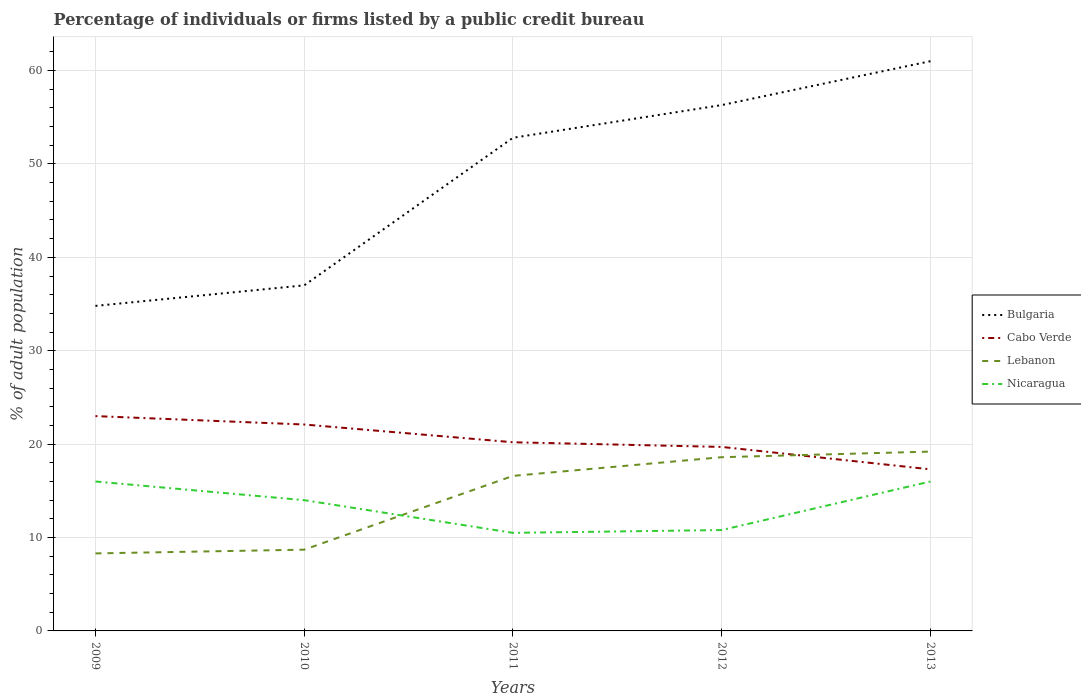Does the line corresponding to Cabo Verde intersect with the line corresponding to Bulgaria?
Your answer should be compact. No. Is the number of lines equal to the number of legend labels?
Keep it short and to the point. Yes. What is the total percentage of population listed by a public credit bureau in Lebanon in the graph?
Provide a short and direct response. -0.4. What is the difference between the highest and the second highest percentage of population listed by a public credit bureau in Lebanon?
Make the answer very short. 10.9. What is the difference between the highest and the lowest percentage of population listed by a public credit bureau in Lebanon?
Ensure brevity in your answer.  3. Is the percentage of population listed by a public credit bureau in Nicaragua strictly greater than the percentage of population listed by a public credit bureau in Lebanon over the years?
Your answer should be compact. No. How many years are there in the graph?
Keep it short and to the point. 5. What is the difference between two consecutive major ticks on the Y-axis?
Give a very brief answer. 10. Does the graph contain grids?
Your answer should be compact. Yes. How many legend labels are there?
Give a very brief answer. 4. What is the title of the graph?
Keep it short and to the point. Percentage of individuals or firms listed by a public credit bureau. What is the label or title of the X-axis?
Provide a succinct answer. Years. What is the label or title of the Y-axis?
Ensure brevity in your answer.  % of adult population. What is the % of adult population of Bulgaria in 2009?
Offer a terse response. 34.8. What is the % of adult population of Lebanon in 2009?
Your answer should be compact. 8.3. What is the % of adult population in Nicaragua in 2009?
Offer a terse response. 16. What is the % of adult population of Bulgaria in 2010?
Make the answer very short. 37. What is the % of adult population of Cabo Verde in 2010?
Your answer should be compact. 22.1. What is the % of adult population of Lebanon in 2010?
Provide a succinct answer. 8.7. What is the % of adult population of Nicaragua in 2010?
Provide a succinct answer. 14. What is the % of adult population of Bulgaria in 2011?
Your answer should be compact. 52.8. What is the % of adult population of Cabo Verde in 2011?
Provide a short and direct response. 20.2. What is the % of adult population of Bulgaria in 2012?
Make the answer very short. 56.3. What is the % of adult population in Lebanon in 2012?
Your response must be concise. 18.6. What is the % of adult population of Bulgaria in 2013?
Make the answer very short. 61. What is the % of adult population of Cabo Verde in 2013?
Keep it short and to the point. 17.3. What is the % of adult population in Lebanon in 2013?
Make the answer very short. 19.2. What is the % of adult population of Nicaragua in 2013?
Provide a succinct answer. 16. Across all years, what is the maximum % of adult population in Bulgaria?
Make the answer very short. 61. Across all years, what is the maximum % of adult population of Cabo Verde?
Offer a terse response. 23. Across all years, what is the maximum % of adult population of Lebanon?
Offer a very short reply. 19.2. Across all years, what is the maximum % of adult population in Nicaragua?
Give a very brief answer. 16. Across all years, what is the minimum % of adult population in Bulgaria?
Offer a very short reply. 34.8. Across all years, what is the minimum % of adult population of Cabo Verde?
Provide a short and direct response. 17.3. Across all years, what is the minimum % of adult population in Nicaragua?
Ensure brevity in your answer.  10.5. What is the total % of adult population in Bulgaria in the graph?
Your response must be concise. 241.9. What is the total % of adult population of Cabo Verde in the graph?
Provide a succinct answer. 102.3. What is the total % of adult population of Lebanon in the graph?
Offer a terse response. 71.4. What is the total % of adult population in Nicaragua in the graph?
Provide a succinct answer. 67.3. What is the difference between the % of adult population in Cabo Verde in 2009 and that in 2010?
Offer a terse response. 0.9. What is the difference between the % of adult population in Nicaragua in 2009 and that in 2010?
Give a very brief answer. 2. What is the difference between the % of adult population of Bulgaria in 2009 and that in 2011?
Give a very brief answer. -18. What is the difference between the % of adult population in Cabo Verde in 2009 and that in 2011?
Offer a terse response. 2.8. What is the difference between the % of adult population in Nicaragua in 2009 and that in 2011?
Provide a succinct answer. 5.5. What is the difference between the % of adult population in Bulgaria in 2009 and that in 2012?
Provide a succinct answer. -21.5. What is the difference between the % of adult population in Cabo Verde in 2009 and that in 2012?
Keep it short and to the point. 3.3. What is the difference between the % of adult population in Bulgaria in 2009 and that in 2013?
Offer a terse response. -26.2. What is the difference between the % of adult population of Nicaragua in 2009 and that in 2013?
Your response must be concise. 0. What is the difference between the % of adult population of Bulgaria in 2010 and that in 2011?
Offer a terse response. -15.8. What is the difference between the % of adult population in Cabo Verde in 2010 and that in 2011?
Your answer should be compact. 1.9. What is the difference between the % of adult population of Nicaragua in 2010 and that in 2011?
Provide a succinct answer. 3.5. What is the difference between the % of adult population of Bulgaria in 2010 and that in 2012?
Ensure brevity in your answer.  -19.3. What is the difference between the % of adult population of Lebanon in 2010 and that in 2012?
Offer a very short reply. -9.9. What is the difference between the % of adult population of Bulgaria in 2010 and that in 2013?
Your answer should be very brief. -24. What is the difference between the % of adult population in Lebanon in 2010 and that in 2013?
Give a very brief answer. -10.5. What is the difference between the % of adult population in Bulgaria in 2011 and that in 2012?
Offer a very short reply. -3.5. What is the difference between the % of adult population of Lebanon in 2011 and that in 2012?
Give a very brief answer. -2. What is the difference between the % of adult population in Nicaragua in 2011 and that in 2012?
Provide a short and direct response. -0.3. What is the difference between the % of adult population of Cabo Verde in 2011 and that in 2013?
Ensure brevity in your answer.  2.9. What is the difference between the % of adult population of Lebanon in 2011 and that in 2013?
Provide a succinct answer. -2.6. What is the difference between the % of adult population in Bulgaria in 2012 and that in 2013?
Provide a short and direct response. -4.7. What is the difference between the % of adult population in Bulgaria in 2009 and the % of adult population in Lebanon in 2010?
Provide a succinct answer. 26.1. What is the difference between the % of adult population of Bulgaria in 2009 and the % of adult population of Nicaragua in 2010?
Give a very brief answer. 20.8. What is the difference between the % of adult population in Cabo Verde in 2009 and the % of adult population in Nicaragua in 2010?
Your answer should be compact. 9. What is the difference between the % of adult population of Bulgaria in 2009 and the % of adult population of Cabo Verde in 2011?
Your answer should be compact. 14.6. What is the difference between the % of adult population of Bulgaria in 2009 and the % of adult population of Nicaragua in 2011?
Keep it short and to the point. 24.3. What is the difference between the % of adult population in Cabo Verde in 2009 and the % of adult population in Lebanon in 2011?
Your answer should be very brief. 6.4. What is the difference between the % of adult population of Bulgaria in 2010 and the % of adult population of Lebanon in 2011?
Your answer should be compact. 20.4. What is the difference between the % of adult population of Cabo Verde in 2010 and the % of adult population of Lebanon in 2011?
Your answer should be very brief. 5.5. What is the difference between the % of adult population in Bulgaria in 2010 and the % of adult population in Lebanon in 2012?
Keep it short and to the point. 18.4. What is the difference between the % of adult population of Bulgaria in 2010 and the % of adult population of Nicaragua in 2012?
Give a very brief answer. 26.2. What is the difference between the % of adult population in Cabo Verde in 2010 and the % of adult population in Lebanon in 2012?
Make the answer very short. 3.5. What is the difference between the % of adult population of Cabo Verde in 2010 and the % of adult population of Nicaragua in 2012?
Your response must be concise. 11.3. What is the difference between the % of adult population of Lebanon in 2010 and the % of adult population of Nicaragua in 2012?
Keep it short and to the point. -2.1. What is the difference between the % of adult population in Bulgaria in 2010 and the % of adult population in Lebanon in 2013?
Provide a succinct answer. 17.8. What is the difference between the % of adult population of Bulgaria in 2010 and the % of adult population of Nicaragua in 2013?
Your answer should be very brief. 21. What is the difference between the % of adult population of Lebanon in 2010 and the % of adult population of Nicaragua in 2013?
Ensure brevity in your answer.  -7.3. What is the difference between the % of adult population in Bulgaria in 2011 and the % of adult population in Cabo Verde in 2012?
Provide a succinct answer. 33.1. What is the difference between the % of adult population of Bulgaria in 2011 and the % of adult population of Lebanon in 2012?
Your response must be concise. 34.2. What is the difference between the % of adult population in Bulgaria in 2011 and the % of adult population in Nicaragua in 2012?
Your answer should be compact. 42. What is the difference between the % of adult population of Lebanon in 2011 and the % of adult population of Nicaragua in 2012?
Offer a very short reply. 5.8. What is the difference between the % of adult population in Bulgaria in 2011 and the % of adult population in Cabo Verde in 2013?
Your answer should be very brief. 35.5. What is the difference between the % of adult population in Bulgaria in 2011 and the % of adult population in Lebanon in 2013?
Provide a short and direct response. 33.6. What is the difference between the % of adult population of Bulgaria in 2011 and the % of adult population of Nicaragua in 2013?
Your response must be concise. 36.8. What is the difference between the % of adult population in Cabo Verde in 2011 and the % of adult population in Nicaragua in 2013?
Keep it short and to the point. 4.2. What is the difference between the % of adult population in Bulgaria in 2012 and the % of adult population in Lebanon in 2013?
Make the answer very short. 37.1. What is the difference between the % of adult population of Bulgaria in 2012 and the % of adult population of Nicaragua in 2013?
Offer a very short reply. 40.3. What is the difference between the % of adult population of Cabo Verde in 2012 and the % of adult population of Nicaragua in 2013?
Keep it short and to the point. 3.7. What is the average % of adult population of Bulgaria per year?
Make the answer very short. 48.38. What is the average % of adult population in Cabo Verde per year?
Ensure brevity in your answer.  20.46. What is the average % of adult population in Lebanon per year?
Your answer should be compact. 14.28. What is the average % of adult population in Nicaragua per year?
Offer a very short reply. 13.46. In the year 2009, what is the difference between the % of adult population in Bulgaria and % of adult population in Cabo Verde?
Provide a succinct answer. 11.8. In the year 2009, what is the difference between the % of adult population in Bulgaria and % of adult population in Nicaragua?
Provide a short and direct response. 18.8. In the year 2009, what is the difference between the % of adult population of Cabo Verde and % of adult population of Nicaragua?
Your response must be concise. 7. In the year 2010, what is the difference between the % of adult population of Bulgaria and % of adult population of Cabo Verde?
Offer a very short reply. 14.9. In the year 2010, what is the difference between the % of adult population in Bulgaria and % of adult population in Lebanon?
Keep it short and to the point. 28.3. In the year 2010, what is the difference between the % of adult population in Bulgaria and % of adult population in Nicaragua?
Your answer should be compact. 23. In the year 2010, what is the difference between the % of adult population of Cabo Verde and % of adult population of Lebanon?
Offer a terse response. 13.4. In the year 2011, what is the difference between the % of adult population of Bulgaria and % of adult population of Cabo Verde?
Offer a terse response. 32.6. In the year 2011, what is the difference between the % of adult population of Bulgaria and % of adult population of Lebanon?
Offer a very short reply. 36.2. In the year 2011, what is the difference between the % of adult population in Bulgaria and % of adult population in Nicaragua?
Make the answer very short. 42.3. In the year 2011, what is the difference between the % of adult population of Cabo Verde and % of adult population of Lebanon?
Provide a succinct answer. 3.6. In the year 2011, what is the difference between the % of adult population in Lebanon and % of adult population in Nicaragua?
Make the answer very short. 6.1. In the year 2012, what is the difference between the % of adult population of Bulgaria and % of adult population of Cabo Verde?
Your answer should be very brief. 36.6. In the year 2012, what is the difference between the % of adult population of Bulgaria and % of adult population of Lebanon?
Make the answer very short. 37.7. In the year 2012, what is the difference between the % of adult population in Bulgaria and % of adult population in Nicaragua?
Ensure brevity in your answer.  45.5. In the year 2012, what is the difference between the % of adult population of Cabo Verde and % of adult population of Lebanon?
Your answer should be very brief. 1.1. In the year 2012, what is the difference between the % of adult population in Cabo Verde and % of adult population in Nicaragua?
Provide a succinct answer. 8.9. In the year 2012, what is the difference between the % of adult population of Lebanon and % of adult population of Nicaragua?
Offer a terse response. 7.8. In the year 2013, what is the difference between the % of adult population of Bulgaria and % of adult population of Cabo Verde?
Ensure brevity in your answer.  43.7. In the year 2013, what is the difference between the % of adult population of Bulgaria and % of adult population of Lebanon?
Keep it short and to the point. 41.8. In the year 2013, what is the difference between the % of adult population of Bulgaria and % of adult population of Nicaragua?
Provide a succinct answer. 45. In the year 2013, what is the difference between the % of adult population of Cabo Verde and % of adult population of Lebanon?
Your answer should be compact. -1.9. In the year 2013, what is the difference between the % of adult population in Lebanon and % of adult population in Nicaragua?
Make the answer very short. 3.2. What is the ratio of the % of adult population of Bulgaria in 2009 to that in 2010?
Your response must be concise. 0.94. What is the ratio of the % of adult population of Cabo Verde in 2009 to that in 2010?
Make the answer very short. 1.04. What is the ratio of the % of adult population of Lebanon in 2009 to that in 2010?
Provide a succinct answer. 0.95. What is the ratio of the % of adult population of Bulgaria in 2009 to that in 2011?
Make the answer very short. 0.66. What is the ratio of the % of adult population in Cabo Verde in 2009 to that in 2011?
Provide a succinct answer. 1.14. What is the ratio of the % of adult population in Lebanon in 2009 to that in 2011?
Offer a terse response. 0.5. What is the ratio of the % of adult population in Nicaragua in 2009 to that in 2011?
Ensure brevity in your answer.  1.52. What is the ratio of the % of adult population of Bulgaria in 2009 to that in 2012?
Offer a terse response. 0.62. What is the ratio of the % of adult population in Cabo Verde in 2009 to that in 2012?
Offer a very short reply. 1.17. What is the ratio of the % of adult population of Lebanon in 2009 to that in 2012?
Your answer should be compact. 0.45. What is the ratio of the % of adult population of Nicaragua in 2009 to that in 2012?
Provide a succinct answer. 1.48. What is the ratio of the % of adult population in Bulgaria in 2009 to that in 2013?
Give a very brief answer. 0.57. What is the ratio of the % of adult population of Cabo Verde in 2009 to that in 2013?
Your answer should be very brief. 1.33. What is the ratio of the % of adult population in Lebanon in 2009 to that in 2013?
Offer a very short reply. 0.43. What is the ratio of the % of adult population of Bulgaria in 2010 to that in 2011?
Make the answer very short. 0.7. What is the ratio of the % of adult population of Cabo Verde in 2010 to that in 2011?
Your answer should be very brief. 1.09. What is the ratio of the % of adult population of Lebanon in 2010 to that in 2011?
Offer a very short reply. 0.52. What is the ratio of the % of adult population of Nicaragua in 2010 to that in 2011?
Offer a very short reply. 1.33. What is the ratio of the % of adult population of Bulgaria in 2010 to that in 2012?
Provide a short and direct response. 0.66. What is the ratio of the % of adult population of Cabo Verde in 2010 to that in 2012?
Give a very brief answer. 1.12. What is the ratio of the % of adult population in Lebanon in 2010 to that in 2012?
Your response must be concise. 0.47. What is the ratio of the % of adult population in Nicaragua in 2010 to that in 2012?
Your response must be concise. 1.3. What is the ratio of the % of adult population of Bulgaria in 2010 to that in 2013?
Keep it short and to the point. 0.61. What is the ratio of the % of adult population in Cabo Verde in 2010 to that in 2013?
Give a very brief answer. 1.28. What is the ratio of the % of adult population of Lebanon in 2010 to that in 2013?
Provide a short and direct response. 0.45. What is the ratio of the % of adult population in Bulgaria in 2011 to that in 2012?
Provide a succinct answer. 0.94. What is the ratio of the % of adult population of Cabo Verde in 2011 to that in 2012?
Your answer should be very brief. 1.03. What is the ratio of the % of adult population in Lebanon in 2011 to that in 2012?
Your answer should be compact. 0.89. What is the ratio of the % of adult population of Nicaragua in 2011 to that in 2012?
Make the answer very short. 0.97. What is the ratio of the % of adult population of Bulgaria in 2011 to that in 2013?
Make the answer very short. 0.87. What is the ratio of the % of adult population in Cabo Verde in 2011 to that in 2013?
Your answer should be compact. 1.17. What is the ratio of the % of adult population in Lebanon in 2011 to that in 2013?
Make the answer very short. 0.86. What is the ratio of the % of adult population in Nicaragua in 2011 to that in 2013?
Provide a short and direct response. 0.66. What is the ratio of the % of adult population in Bulgaria in 2012 to that in 2013?
Your answer should be very brief. 0.92. What is the ratio of the % of adult population of Cabo Verde in 2012 to that in 2013?
Keep it short and to the point. 1.14. What is the ratio of the % of adult population in Lebanon in 2012 to that in 2013?
Provide a succinct answer. 0.97. What is the ratio of the % of adult population in Nicaragua in 2012 to that in 2013?
Give a very brief answer. 0.68. What is the difference between the highest and the second highest % of adult population of Bulgaria?
Keep it short and to the point. 4.7. What is the difference between the highest and the second highest % of adult population of Lebanon?
Ensure brevity in your answer.  0.6. What is the difference between the highest and the lowest % of adult population of Bulgaria?
Ensure brevity in your answer.  26.2. 